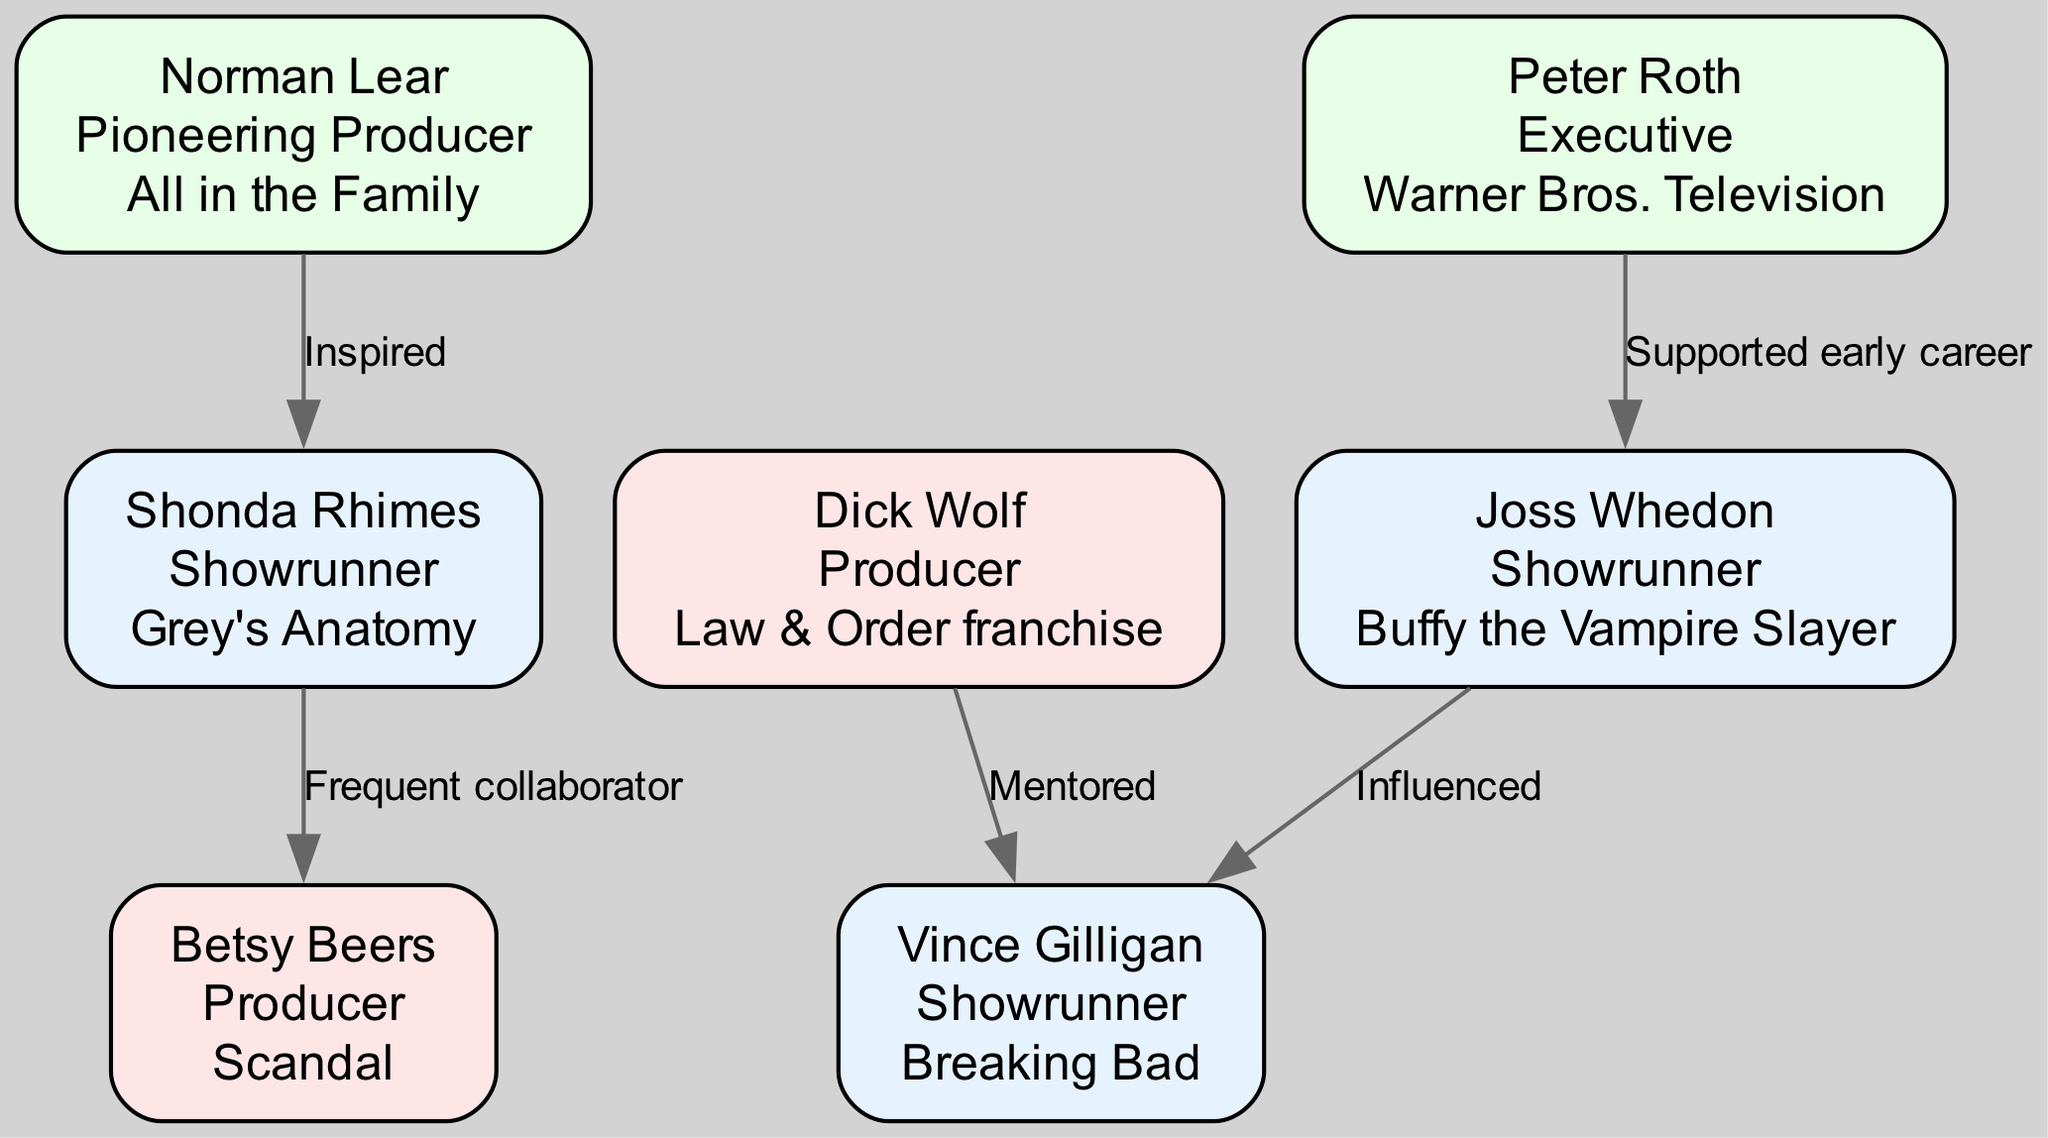What is the notable work of Norman Lear? According to the diagram, Norman Lear has "All in the Family" listed as his notable work. This information can be found directly under his name in the node representing him.
Answer: All in the Family Who is the frequent collaborator of Shonda Rhimes? The diagram indicates that Betsy Beers is labeled as a "Frequent collaborator" with Shonda Rhimes. This relationship is directly illustrated by the edge connecting their nodes with the corresponding label.
Answer: Betsy Beers How many nodes are in the diagram? By counting the individual nodes in the diagram, there are a total of seven distinct producers and showrunners represented, each as a separate node.
Answer: 7 What relationship exists between Dick Wolf and Vince Gilligan? The edge connecting Dick Wolf and Vince Gilligan indicates a "Mentored" relationship. This can be seen by examining the connections between their respective nodes and the label on the edge.
Answer: Mentored Which producer supported the early career of Joss Whedon? The diagram shows that Peter Roth is the one who "Supported early career" of Joss Whedon, as depicted in the connection between their nodes. This relationship is highlighted by the edge linking them with the defined label.
Answer: Peter Roth How many relationships does Norman Lear have in the diagram? By inspecting the edges connected to Norman Lear's node, it is clear that he has one relationship, which is "Inspired" towards Shonda Rhimes. Since there is only one edge linking to him, the count is one.
Answer: 1 What notable work is associated with Joss Whedon? The diagram states that Joss Whedon's notable work is "Buffy the Vampire Slayer." This information can be easily identified within the node corresponding to Joss Whedon.
Answer: Buffy the Vampire Slayer Who has the role of Showrunner besides Shonda Rhimes? By checking the nodes in the diagram, besides Shonda Rhimes, the other individual with the role of Showrunner listed is Joss Whedon and Vince Gilligan. Both are indicated clearly under their names as Showrunners.
Answer: Joss Whedon, Vince Gilligan What type of connection is between Joss Whedon and Vince Gilligan? The relationship depicted between Joss Whedon and Vince Gilligan is labeled "Influenced." This is observable in the edge that connects their nodes, indicating the nature of their relationship.
Answer: Influenced 